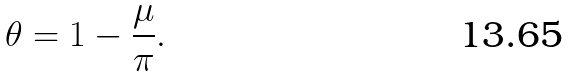Convert formula to latex. <formula><loc_0><loc_0><loc_500><loc_500>\theta = 1 - \frac { \mu } { \pi } .</formula> 